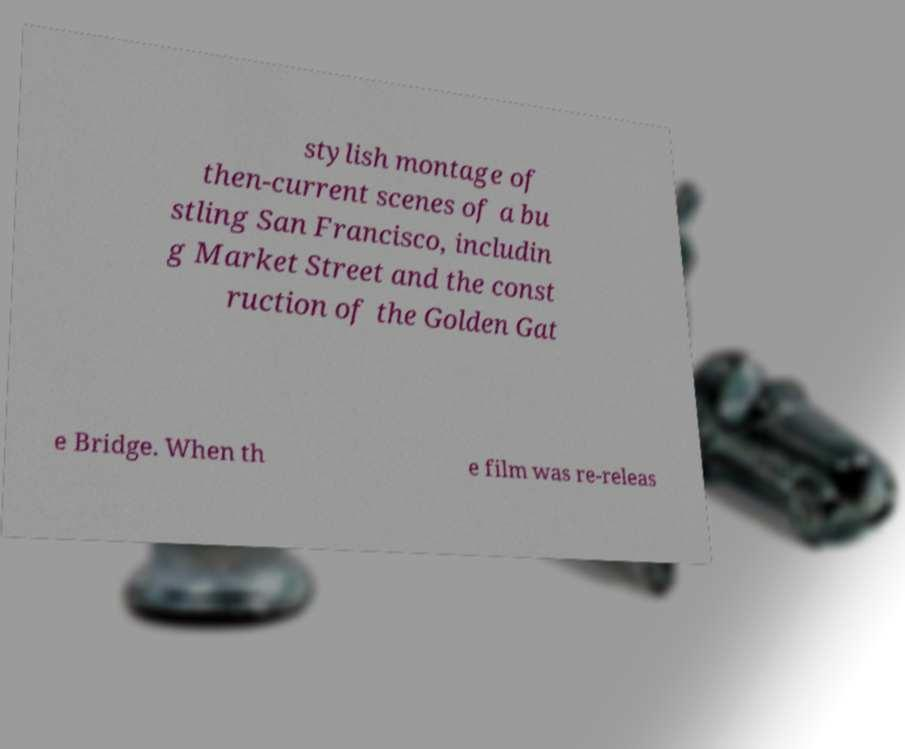I need the written content from this picture converted into text. Can you do that? stylish montage of then-current scenes of a bu stling San Francisco, includin g Market Street and the const ruction of the Golden Gat e Bridge. When th e film was re-releas 